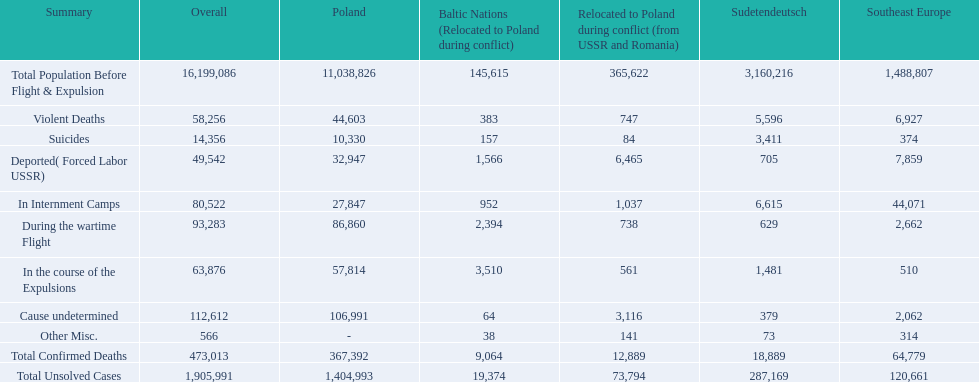What are the numbers of violent deaths across the area? 44,603, 383, 747, 5,596, 6,927. What is the total number of violent deaths of the area? 58,256. 